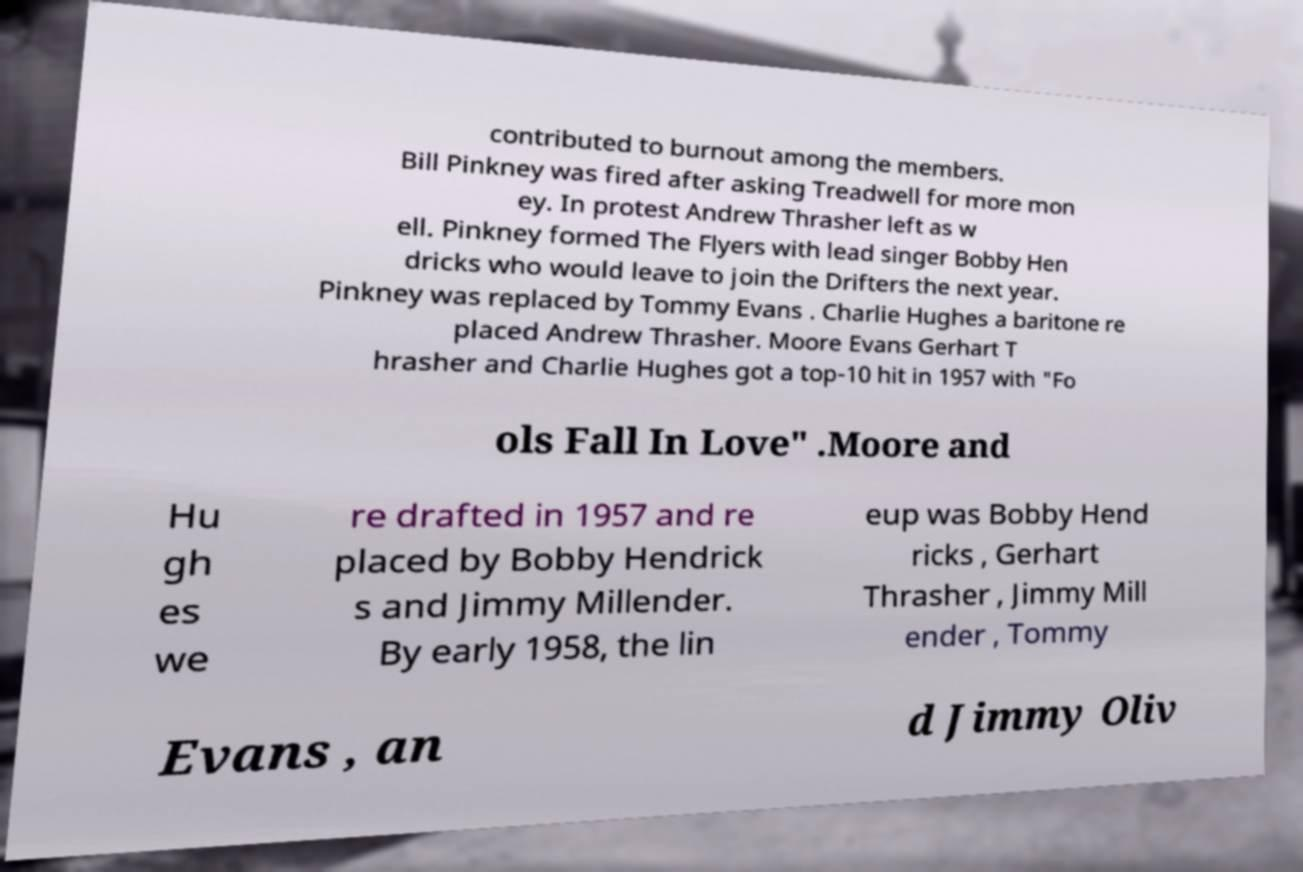I need the written content from this picture converted into text. Can you do that? contributed to burnout among the members. Bill Pinkney was fired after asking Treadwell for more mon ey. In protest Andrew Thrasher left as w ell. Pinkney formed The Flyers with lead singer Bobby Hen dricks who would leave to join the Drifters the next year. Pinkney was replaced by Tommy Evans . Charlie Hughes a baritone re placed Andrew Thrasher. Moore Evans Gerhart T hrasher and Charlie Hughes got a top-10 hit in 1957 with "Fo ols Fall In Love" .Moore and Hu gh es we re drafted in 1957 and re placed by Bobby Hendrick s and Jimmy Millender. By early 1958, the lin eup was Bobby Hend ricks , Gerhart Thrasher , Jimmy Mill ender , Tommy Evans , an d Jimmy Oliv 